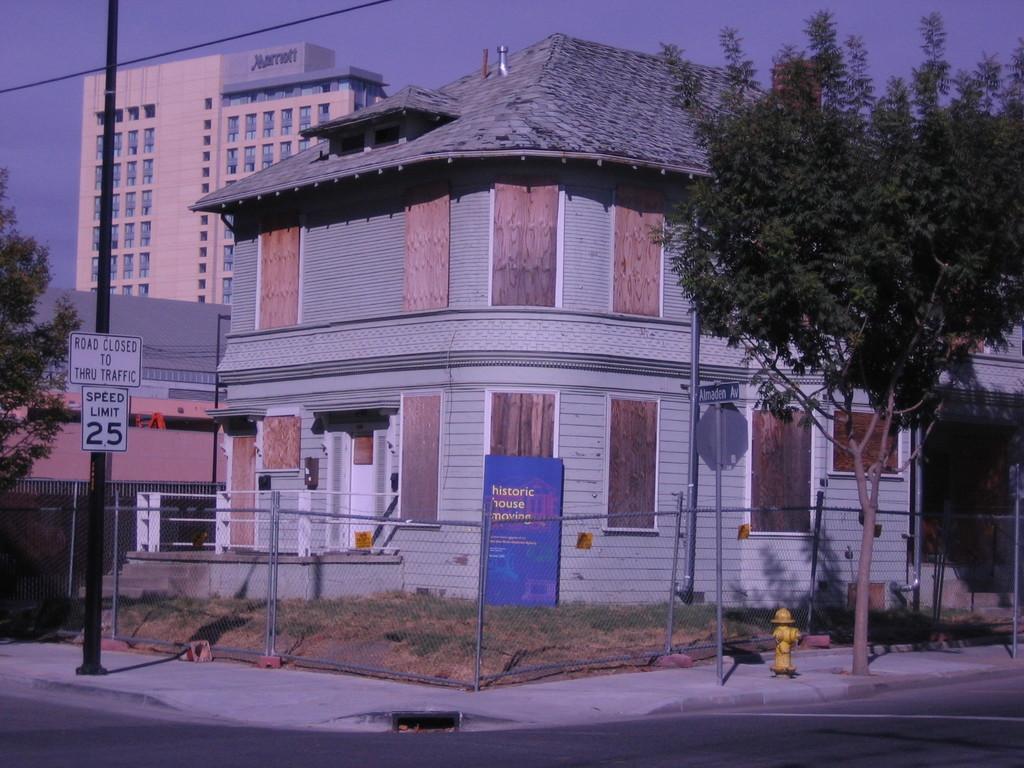How would you summarize this image in a sentence or two? In this image, we can see a building and shelter house. There is a tree on the left and on the right side of the image. There is a pole beside the road. There is a fence at the bottom of the image. There is a sky at the top of the image. 